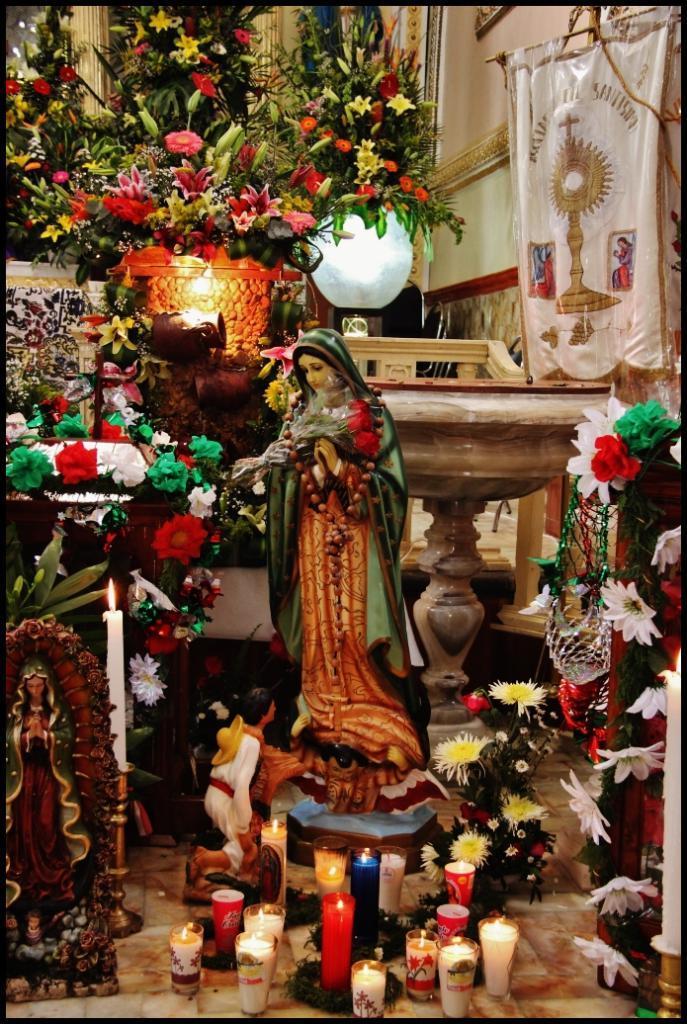Please provide a concise description of this image. In this image we can see some miniature statues and candles on the floor. 